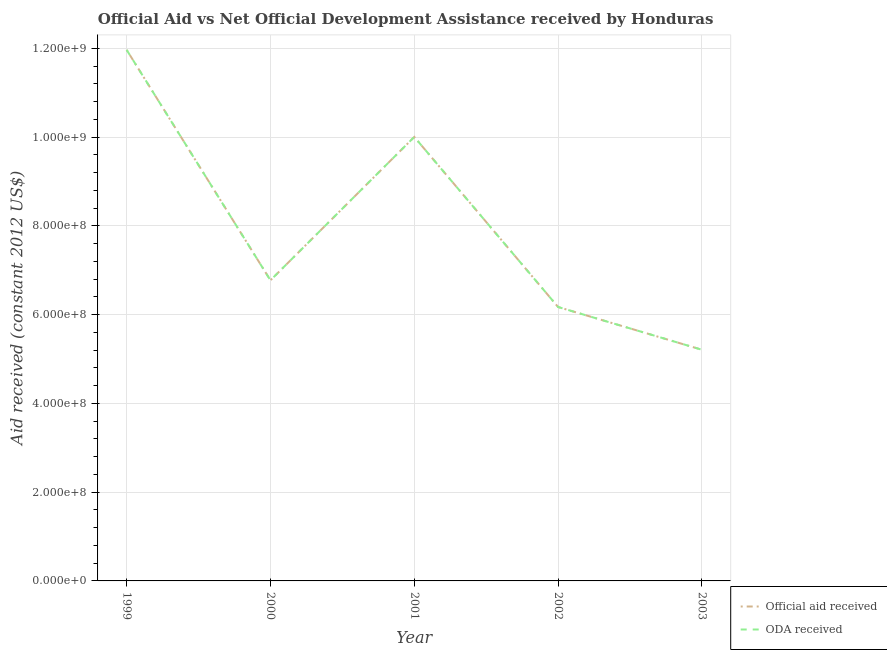Does the line corresponding to official aid received intersect with the line corresponding to oda received?
Offer a terse response. Yes. Is the number of lines equal to the number of legend labels?
Ensure brevity in your answer.  Yes. What is the official aid received in 1999?
Offer a very short reply. 1.20e+09. Across all years, what is the maximum official aid received?
Offer a terse response. 1.20e+09. Across all years, what is the minimum oda received?
Provide a short and direct response. 5.21e+08. In which year was the oda received maximum?
Offer a terse response. 1999. In which year was the oda received minimum?
Keep it short and to the point. 2003. What is the total oda received in the graph?
Keep it short and to the point. 4.01e+09. What is the difference between the oda received in 2000 and that in 2003?
Provide a short and direct response. 1.57e+08. What is the difference between the official aid received in 1999 and the oda received in 2000?
Ensure brevity in your answer.  5.19e+08. What is the average official aid received per year?
Your answer should be compact. 8.02e+08. What is the ratio of the oda received in 1999 to that in 2000?
Make the answer very short. 1.77. Is the difference between the oda received in 1999 and 2000 greater than the difference between the official aid received in 1999 and 2000?
Your answer should be very brief. No. What is the difference between the highest and the second highest oda received?
Keep it short and to the point. 1.96e+08. What is the difference between the highest and the lowest oda received?
Your answer should be compact. 6.76e+08. In how many years, is the oda received greater than the average oda received taken over all years?
Your answer should be very brief. 2. Does the official aid received monotonically increase over the years?
Your answer should be compact. No. Is the official aid received strictly greater than the oda received over the years?
Your answer should be compact. No. Is the oda received strictly less than the official aid received over the years?
Ensure brevity in your answer.  No. How many lines are there?
Give a very brief answer. 2. What is the difference between two consecutive major ticks on the Y-axis?
Ensure brevity in your answer.  2.00e+08. Are the values on the major ticks of Y-axis written in scientific E-notation?
Your answer should be very brief. Yes. Does the graph contain grids?
Provide a succinct answer. Yes. Where does the legend appear in the graph?
Your answer should be very brief. Bottom right. What is the title of the graph?
Your response must be concise. Official Aid vs Net Official Development Assistance received by Honduras . Does "Long-term debt" appear as one of the legend labels in the graph?
Your answer should be very brief. No. What is the label or title of the X-axis?
Offer a terse response. Year. What is the label or title of the Y-axis?
Provide a short and direct response. Aid received (constant 2012 US$). What is the Aid received (constant 2012 US$) of Official aid received in 1999?
Ensure brevity in your answer.  1.20e+09. What is the Aid received (constant 2012 US$) of ODA received in 1999?
Keep it short and to the point. 1.20e+09. What is the Aid received (constant 2012 US$) in Official aid received in 2000?
Give a very brief answer. 6.77e+08. What is the Aid received (constant 2012 US$) of ODA received in 2000?
Make the answer very short. 6.77e+08. What is the Aid received (constant 2012 US$) in Official aid received in 2001?
Offer a terse response. 1.00e+09. What is the Aid received (constant 2012 US$) of ODA received in 2001?
Make the answer very short. 1.00e+09. What is the Aid received (constant 2012 US$) in Official aid received in 2002?
Your response must be concise. 6.17e+08. What is the Aid received (constant 2012 US$) in ODA received in 2002?
Give a very brief answer. 6.17e+08. What is the Aid received (constant 2012 US$) of Official aid received in 2003?
Provide a short and direct response. 5.21e+08. What is the Aid received (constant 2012 US$) in ODA received in 2003?
Offer a terse response. 5.21e+08. Across all years, what is the maximum Aid received (constant 2012 US$) in Official aid received?
Make the answer very short. 1.20e+09. Across all years, what is the maximum Aid received (constant 2012 US$) of ODA received?
Offer a terse response. 1.20e+09. Across all years, what is the minimum Aid received (constant 2012 US$) in Official aid received?
Provide a succinct answer. 5.21e+08. Across all years, what is the minimum Aid received (constant 2012 US$) of ODA received?
Ensure brevity in your answer.  5.21e+08. What is the total Aid received (constant 2012 US$) in Official aid received in the graph?
Give a very brief answer. 4.01e+09. What is the total Aid received (constant 2012 US$) of ODA received in the graph?
Ensure brevity in your answer.  4.01e+09. What is the difference between the Aid received (constant 2012 US$) in Official aid received in 1999 and that in 2000?
Your answer should be very brief. 5.19e+08. What is the difference between the Aid received (constant 2012 US$) of ODA received in 1999 and that in 2000?
Your answer should be very brief. 5.19e+08. What is the difference between the Aid received (constant 2012 US$) of Official aid received in 1999 and that in 2001?
Ensure brevity in your answer.  1.96e+08. What is the difference between the Aid received (constant 2012 US$) of ODA received in 1999 and that in 2001?
Offer a very short reply. 1.96e+08. What is the difference between the Aid received (constant 2012 US$) of Official aid received in 1999 and that in 2002?
Offer a very short reply. 5.79e+08. What is the difference between the Aid received (constant 2012 US$) in ODA received in 1999 and that in 2002?
Keep it short and to the point. 5.79e+08. What is the difference between the Aid received (constant 2012 US$) in Official aid received in 1999 and that in 2003?
Provide a succinct answer. 6.76e+08. What is the difference between the Aid received (constant 2012 US$) of ODA received in 1999 and that in 2003?
Your response must be concise. 6.76e+08. What is the difference between the Aid received (constant 2012 US$) of Official aid received in 2000 and that in 2001?
Ensure brevity in your answer.  -3.23e+08. What is the difference between the Aid received (constant 2012 US$) of ODA received in 2000 and that in 2001?
Give a very brief answer. -3.23e+08. What is the difference between the Aid received (constant 2012 US$) in Official aid received in 2000 and that in 2002?
Offer a very short reply. 6.02e+07. What is the difference between the Aid received (constant 2012 US$) in ODA received in 2000 and that in 2002?
Offer a terse response. 6.02e+07. What is the difference between the Aid received (constant 2012 US$) of Official aid received in 2000 and that in 2003?
Provide a succinct answer. 1.57e+08. What is the difference between the Aid received (constant 2012 US$) in ODA received in 2000 and that in 2003?
Your answer should be very brief. 1.57e+08. What is the difference between the Aid received (constant 2012 US$) in Official aid received in 2001 and that in 2002?
Your answer should be compact. 3.83e+08. What is the difference between the Aid received (constant 2012 US$) in ODA received in 2001 and that in 2002?
Your answer should be compact. 3.83e+08. What is the difference between the Aid received (constant 2012 US$) of Official aid received in 2001 and that in 2003?
Provide a succinct answer. 4.79e+08. What is the difference between the Aid received (constant 2012 US$) of ODA received in 2001 and that in 2003?
Ensure brevity in your answer.  4.79e+08. What is the difference between the Aid received (constant 2012 US$) of Official aid received in 2002 and that in 2003?
Your answer should be compact. 9.63e+07. What is the difference between the Aid received (constant 2012 US$) of ODA received in 2002 and that in 2003?
Provide a short and direct response. 9.63e+07. What is the difference between the Aid received (constant 2012 US$) in Official aid received in 1999 and the Aid received (constant 2012 US$) in ODA received in 2000?
Keep it short and to the point. 5.19e+08. What is the difference between the Aid received (constant 2012 US$) in Official aid received in 1999 and the Aid received (constant 2012 US$) in ODA received in 2001?
Your response must be concise. 1.96e+08. What is the difference between the Aid received (constant 2012 US$) of Official aid received in 1999 and the Aid received (constant 2012 US$) of ODA received in 2002?
Ensure brevity in your answer.  5.79e+08. What is the difference between the Aid received (constant 2012 US$) of Official aid received in 1999 and the Aid received (constant 2012 US$) of ODA received in 2003?
Ensure brevity in your answer.  6.76e+08. What is the difference between the Aid received (constant 2012 US$) of Official aid received in 2000 and the Aid received (constant 2012 US$) of ODA received in 2001?
Give a very brief answer. -3.23e+08. What is the difference between the Aid received (constant 2012 US$) in Official aid received in 2000 and the Aid received (constant 2012 US$) in ODA received in 2002?
Provide a short and direct response. 6.02e+07. What is the difference between the Aid received (constant 2012 US$) of Official aid received in 2000 and the Aid received (constant 2012 US$) of ODA received in 2003?
Keep it short and to the point. 1.57e+08. What is the difference between the Aid received (constant 2012 US$) of Official aid received in 2001 and the Aid received (constant 2012 US$) of ODA received in 2002?
Keep it short and to the point. 3.83e+08. What is the difference between the Aid received (constant 2012 US$) of Official aid received in 2001 and the Aid received (constant 2012 US$) of ODA received in 2003?
Make the answer very short. 4.79e+08. What is the difference between the Aid received (constant 2012 US$) of Official aid received in 2002 and the Aid received (constant 2012 US$) of ODA received in 2003?
Your answer should be very brief. 9.63e+07. What is the average Aid received (constant 2012 US$) in Official aid received per year?
Your answer should be very brief. 8.02e+08. What is the average Aid received (constant 2012 US$) of ODA received per year?
Provide a succinct answer. 8.02e+08. In the year 2003, what is the difference between the Aid received (constant 2012 US$) of Official aid received and Aid received (constant 2012 US$) of ODA received?
Offer a terse response. 0. What is the ratio of the Aid received (constant 2012 US$) of Official aid received in 1999 to that in 2000?
Offer a terse response. 1.77. What is the ratio of the Aid received (constant 2012 US$) in ODA received in 1999 to that in 2000?
Give a very brief answer. 1.77. What is the ratio of the Aid received (constant 2012 US$) of Official aid received in 1999 to that in 2001?
Your answer should be compact. 1.2. What is the ratio of the Aid received (constant 2012 US$) in ODA received in 1999 to that in 2001?
Provide a succinct answer. 1.2. What is the ratio of the Aid received (constant 2012 US$) of Official aid received in 1999 to that in 2002?
Provide a short and direct response. 1.94. What is the ratio of the Aid received (constant 2012 US$) of ODA received in 1999 to that in 2002?
Provide a succinct answer. 1.94. What is the ratio of the Aid received (constant 2012 US$) in Official aid received in 1999 to that in 2003?
Ensure brevity in your answer.  2.3. What is the ratio of the Aid received (constant 2012 US$) of ODA received in 1999 to that in 2003?
Provide a short and direct response. 2.3. What is the ratio of the Aid received (constant 2012 US$) of Official aid received in 2000 to that in 2001?
Make the answer very short. 0.68. What is the ratio of the Aid received (constant 2012 US$) of ODA received in 2000 to that in 2001?
Ensure brevity in your answer.  0.68. What is the ratio of the Aid received (constant 2012 US$) in Official aid received in 2000 to that in 2002?
Make the answer very short. 1.1. What is the ratio of the Aid received (constant 2012 US$) of ODA received in 2000 to that in 2002?
Provide a succinct answer. 1.1. What is the ratio of the Aid received (constant 2012 US$) of Official aid received in 2000 to that in 2003?
Offer a very short reply. 1.3. What is the ratio of the Aid received (constant 2012 US$) in ODA received in 2000 to that in 2003?
Make the answer very short. 1.3. What is the ratio of the Aid received (constant 2012 US$) in Official aid received in 2001 to that in 2002?
Your answer should be very brief. 1.62. What is the ratio of the Aid received (constant 2012 US$) in ODA received in 2001 to that in 2002?
Offer a terse response. 1.62. What is the ratio of the Aid received (constant 2012 US$) in Official aid received in 2001 to that in 2003?
Provide a succinct answer. 1.92. What is the ratio of the Aid received (constant 2012 US$) in ODA received in 2001 to that in 2003?
Make the answer very short. 1.92. What is the ratio of the Aid received (constant 2012 US$) in Official aid received in 2002 to that in 2003?
Give a very brief answer. 1.19. What is the ratio of the Aid received (constant 2012 US$) of ODA received in 2002 to that in 2003?
Provide a short and direct response. 1.19. What is the difference between the highest and the second highest Aid received (constant 2012 US$) of Official aid received?
Your response must be concise. 1.96e+08. What is the difference between the highest and the second highest Aid received (constant 2012 US$) of ODA received?
Provide a succinct answer. 1.96e+08. What is the difference between the highest and the lowest Aid received (constant 2012 US$) of Official aid received?
Give a very brief answer. 6.76e+08. What is the difference between the highest and the lowest Aid received (constant 2012 US$) of ODA received?
Offer a very short reply. 6.76e+08. 